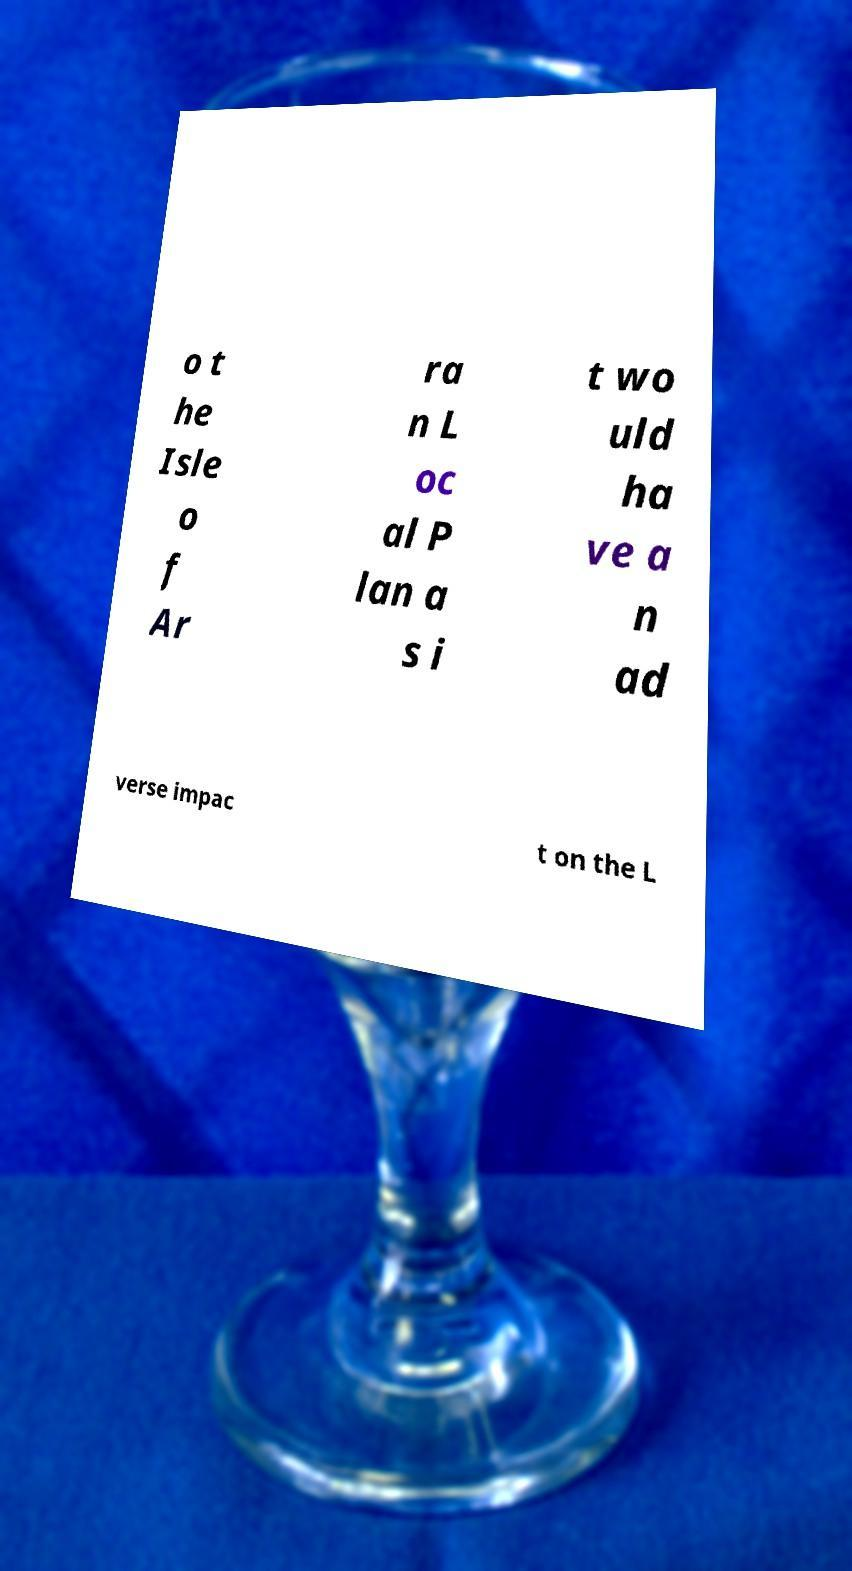What messages or text are displayed in this image? I need them in a readable, typed format. o t he Isle o f Ar ra n L oc al P lan a s i t wo uld ha ve a n ad verse impac t on the L 